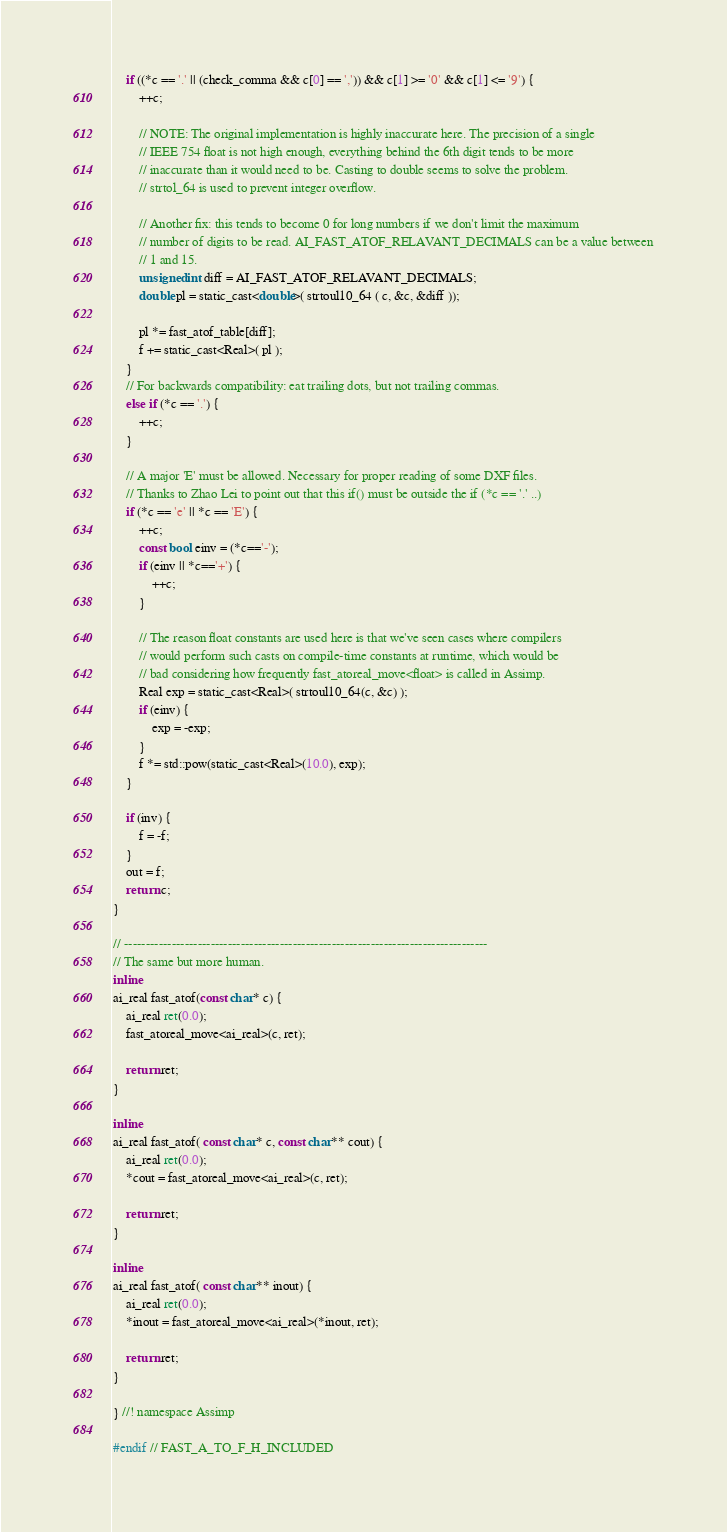<code> <loc_0><loc_0><loc_500><loc_500><_C_>
    if ((*c == '.' || (check_comma && c[0] == ',')) && c[1] >= '0' && c[1] <= '9') {
        ++c;

        // NOTE: The original implementation is highly inaccurate here. The precision of a single
        // IEEE 754 float is not high enough, everything behind the 6th digit tends to be more
        // inaccurate than it would need to be. Casting to double seems to solve the problem.
        // strtol_64 is used to prevent integer overflow.

        // Another fix: this tends to become 0 for long numbers if we don't limit the maximum
        // number of digits to be read. AI_FAST_ATOF_RELAVANT_DECIMALS can be a value between
        // 1 and 15.
        unsigned int diff = AI_FAST_ATOF_RELAVANT_DECIMALS;
        double pl = static_cast<double>( strtoul10_64 ( c, &c, &diff ));

        pl *= fast_atof_table[diff];
        f += static_cast<Real>( pl );
    }
    // For backwards compatibility: eat trailing dots, but not trailing commas.
    else if (*c == '.') {
        ++c;
    }

    // A major 'E' must be allowed. Necessary for proper reading of some DXF files.
    // Thanks to Zhao Lei to point out that this if() must be outside the if (*c == '.' ..)
    if (*c == 'e' || *c == 'E') {
        ++c;
        const bool einv = (*c=='-');
        if (einv || *c=='+') {
            ++c;
        }

        // The reason float constants are used here is that we've seen cases where compilers
        // would perform such casts on compile-time constants at runtime, which would be
        // bad considering how frequently fast_atoreal_move<float> is called in Assimp.
        Real exp = static_cast<Real>( strtoul10_64(c, &c) );
        if (einv) {
            exp = -exp;
        }
        f *= std::pow(static_cast<Real>(10.0), exp);
    }

    if (inv) {
        f = -f;
    }
    out = f;
    return c;
}

// ------------------------------------------------------------------------------------
// The same but more human.
inline
ai_real fast_atof(const char* c) {
    ai_real ret(0.0);
    fast_atoreal_move<ai_real>(c, ret);

    return ret;
}

inline
ai_real fast_atof( const char* c, const char** cout) {
    ai_real ret(0.0);
    *cout = fast_atoreal_move<ai_real>(c, ret);

    return ret;
}

inline
ai_real fast_atof( const char** inout) {
    ai_real ret(0.0);
    *inout = fast_atoreal_move<ai_real>(*inout, ret);

    return ret;
}

} //! namespace Assimp

#endif // FAST_A_TO_F_H_INCLUDED
</code> 